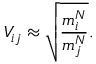<formula> <loc_0><loc_0><loc_500><loc_500>V _ { i j } \approx \sqrt { \frac { m _ { i } ^ { N } } { m _ { j } ^ { N } } } .</formula> 